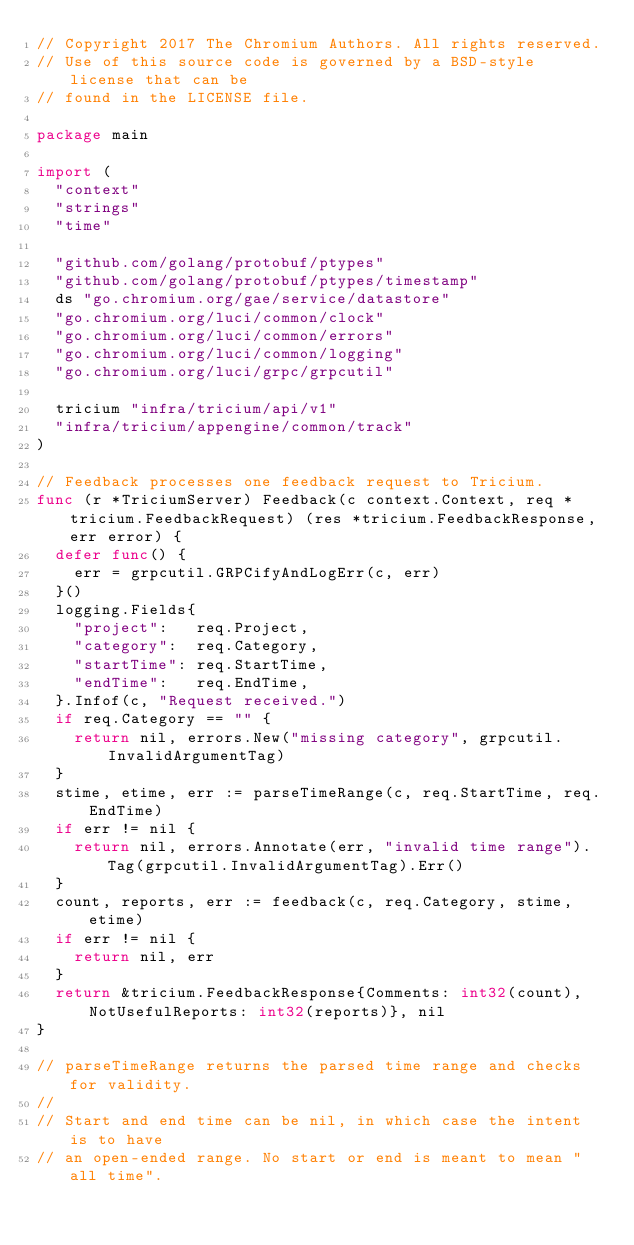Convert code to text. <code><loc_0><loc_0><loc_500><loc_500><_Go_>// Copyright 2017 The Chromium Authors. All rights reserved.
// Use of this source code is governed by a BSD-style license that can be
// found in the LICENSE file.

package main

import (
	"context"
	"strings"
	"time"

	"github.com/golang/protobuf/ptypes"
	"github.com/golang/protobuf/ptypes/timestamp"
	ds "go.chromium.org/gae/service/datastore"
	"go.chromium.org/luci/common/clock"
	"go.chromium.org/luci/common/errors"
	"go.chromium.org/luci/common/logging"
	"go.chromium.org/luci/grpc/grpcutil"

	tricium "infra/tricium/api/v1"
	"infra/tricium/appengine/common/track"
)

// Feedback processes one feedback request to Tricium.
func (r *TriciumServer) Feedback(c context.Context, req *tricium.FeedbackRequest) (res *tricium.FeedbackResponse, err error) {
	defer func() {
		err = grpcutil.GRPCifyAndLogErr(c, err)
	}()
	logging.Fields{
		"project":   req.Project,
		"category":  req.Category,
		"startTime": req.StartTime,
		"endTime":   req.EndTime,
	}.Infof(c, "Request received.")
	if req.Category == "" {
		return nil, errors.New("missing category", grpcutil.InvalidArgumentTag)
	}
	stime, etime, err := parseTimeRange(c, req.StartTime, req.EndTime)
	if err != nil {
		return nil, errors.Annotate(err, "invalid time range").Tag(grpcutil.InvalidArgumentTag).Err()
	}
	count, reports, err := feedback(c, req.Category, stime, etime)
	if err != nil {
		return nil, err
	}
	return &tricium.FeedbackResponse{Comments: int32(count), NotUsefulReports: int32(reports)}, nil
}

// parseTimeRange returns the parsed time range and checks for validity.
//
// Start and end time can be nil, in which case the intent is to have
// an open-ended range. No start or end is meant to mean "all time".</code> 